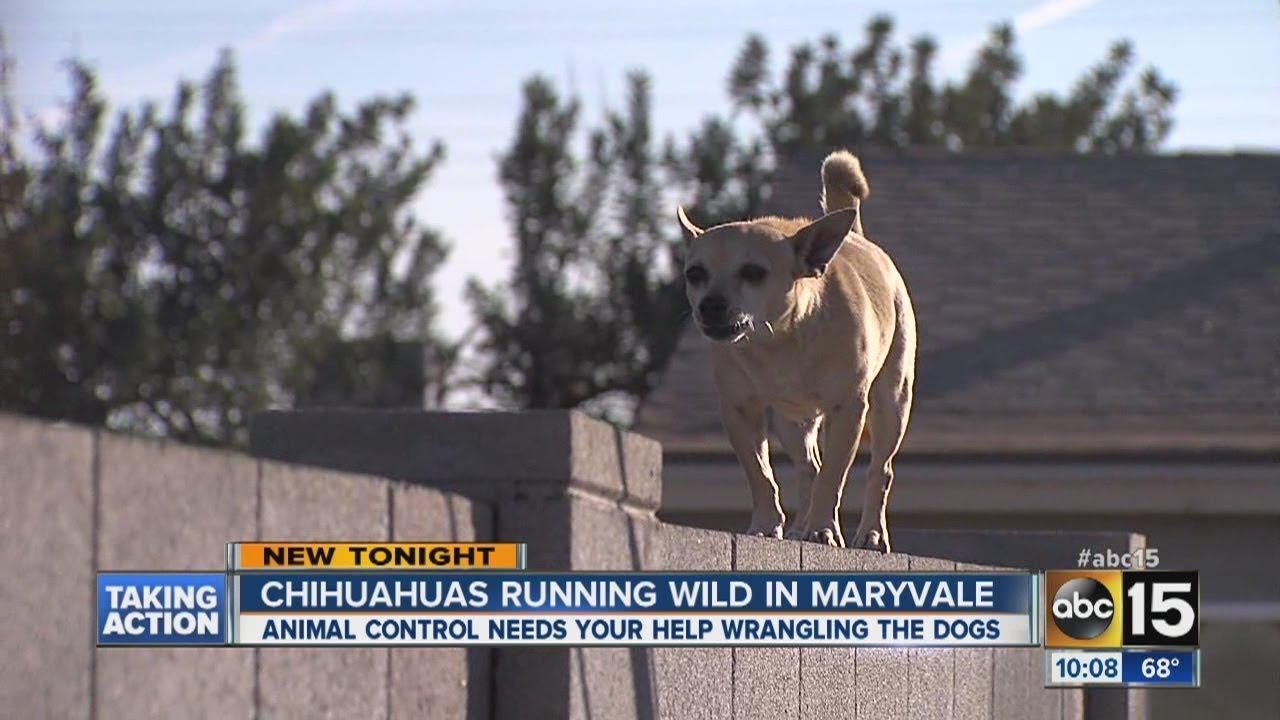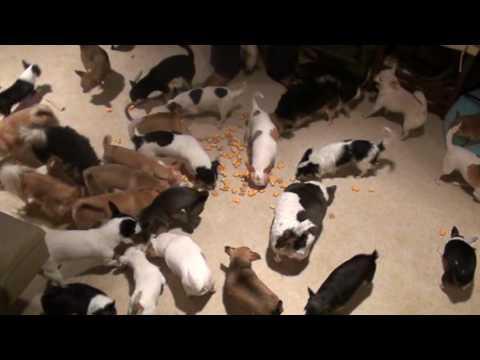The first image is the image on the left, the second image is the image on the right. For the images shown, is this caption "There is exactly one animal in one of the images." true? Answer yes or no. Yes. 